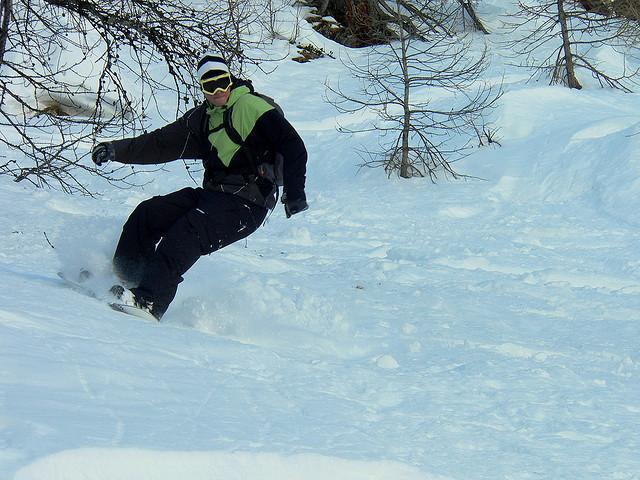How many boats in the water?
Give a very brief answer. 0. 